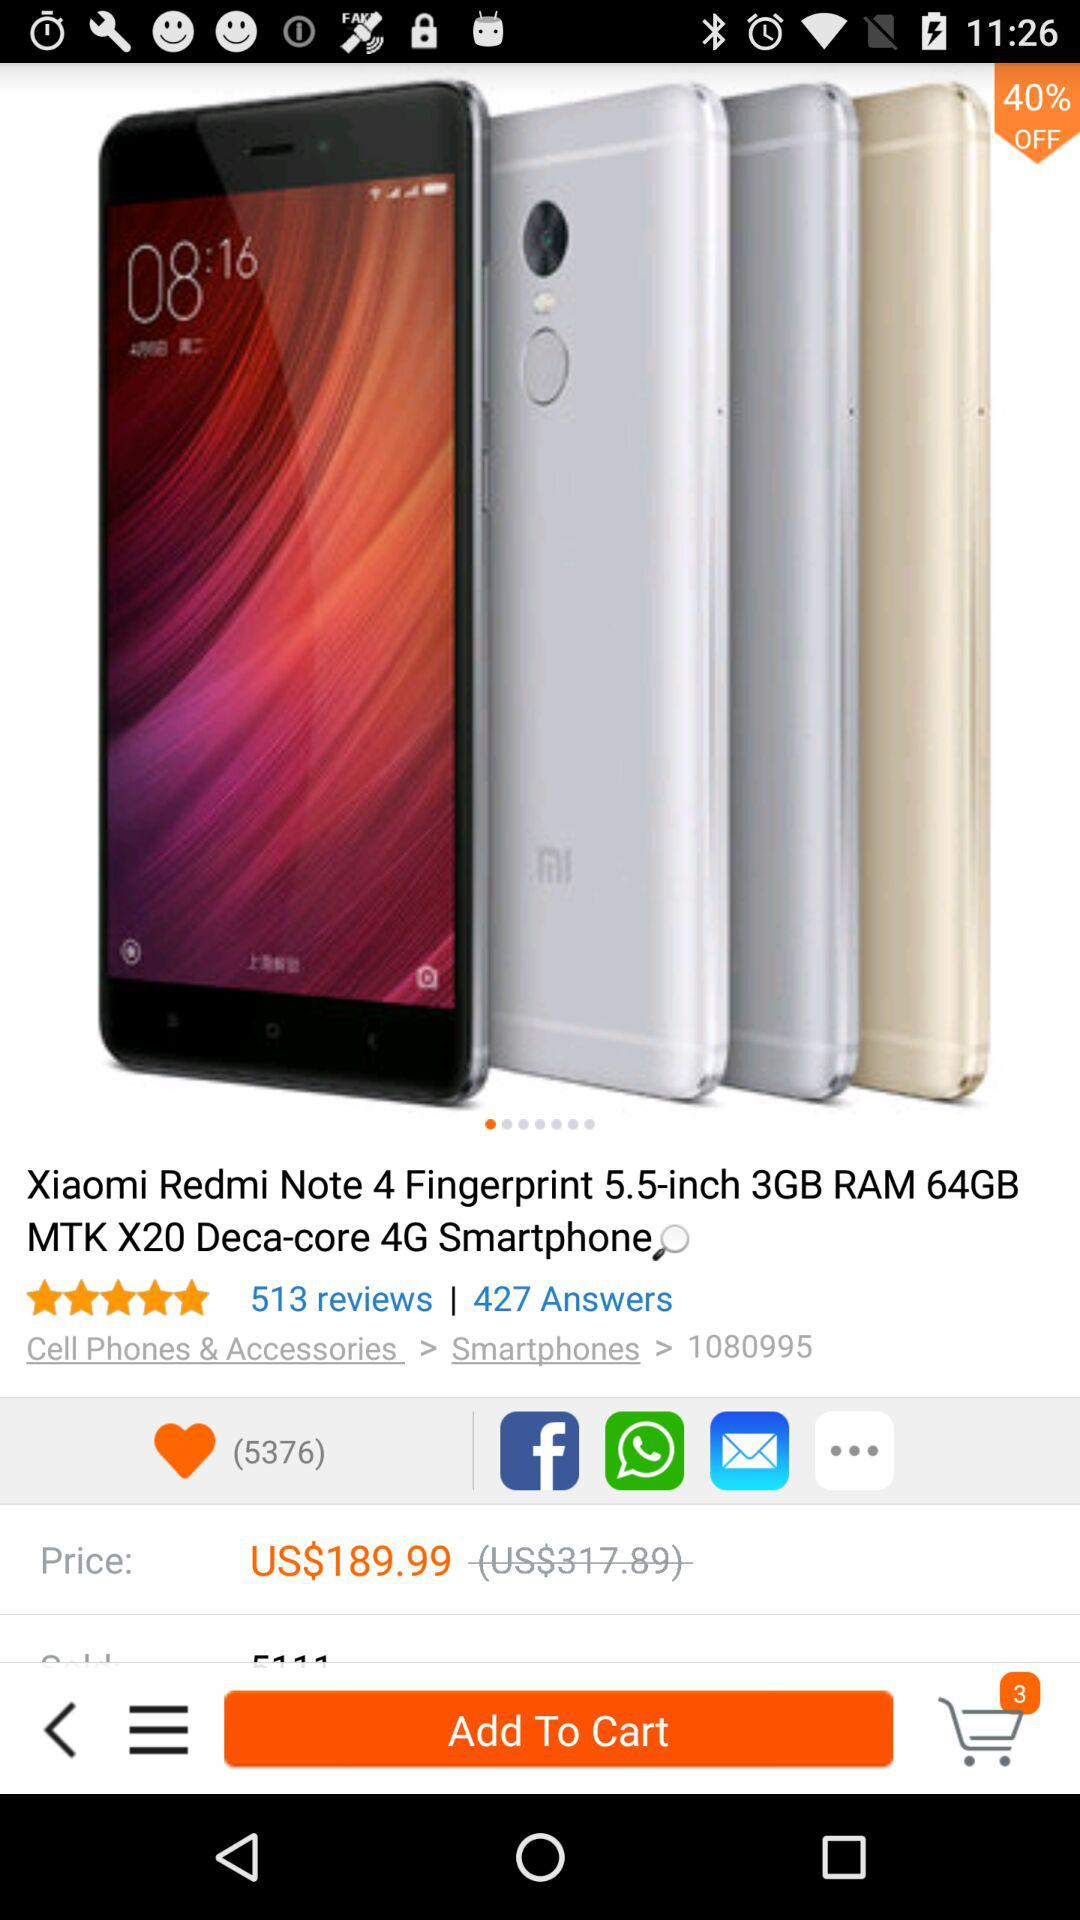What is the number of answers? The number of answers is 427. 